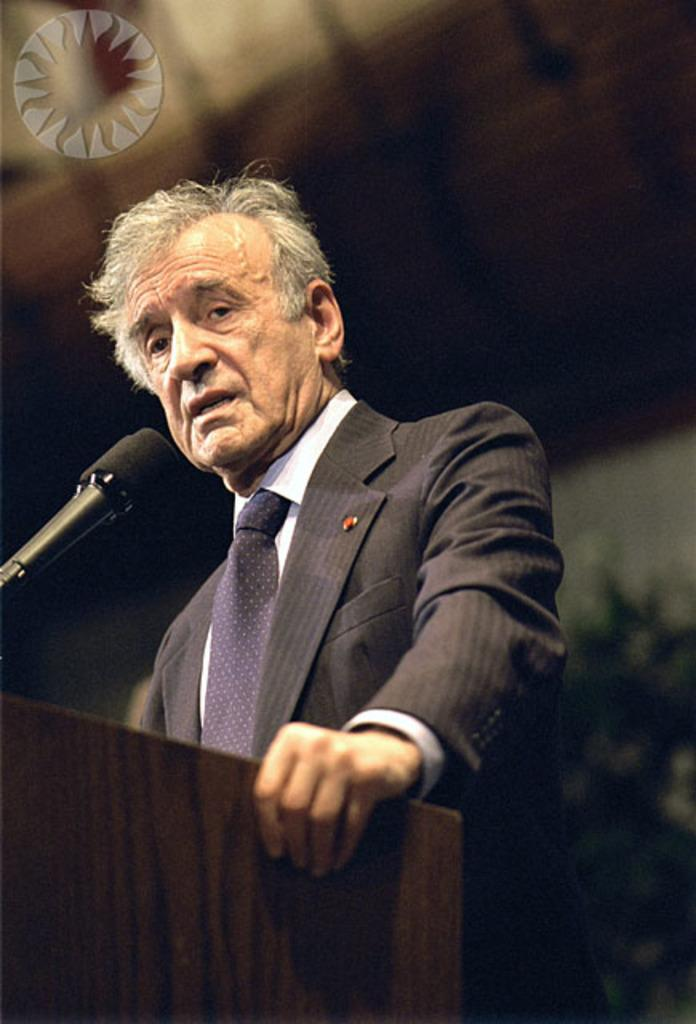Who or what is the main subject in the image? There is a person in the image. What is the person doing in the image? The person is standing in front of a podium. What object is in front of the person? There is a microphone (mike) in front of the person. What type of ring can be seen on the person's finger in the image? There is no ring visible on the person's finger in the image. What route is the person taking while standing in front of the podium? The person is not taking any route while standing in front of the podium; they are stationary. 